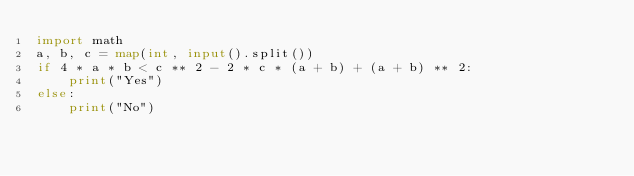Convert code to text. <code><loc_0><loc_0><loc_500><loc_500><_Python_>import math
a, b, c = map(int, input().split())
if 4 * a * b < c ** 2 - 2 * c * (a + b) + (a + b) ** 2:
    print("Yes")
else:
    print("No")
</code> 